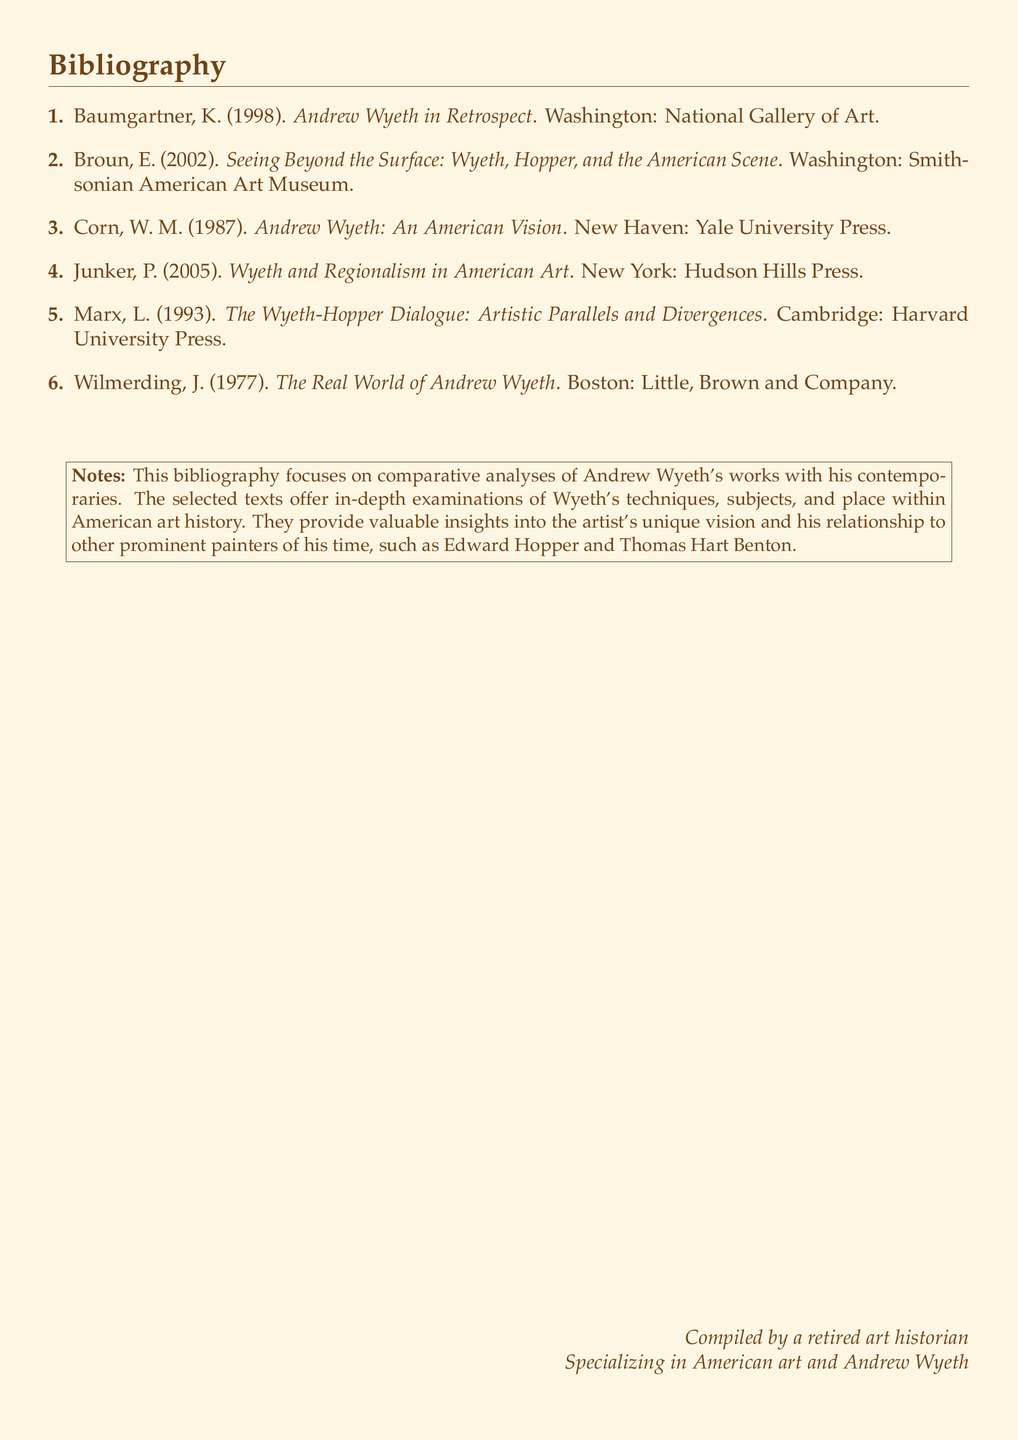What is the title of the book by K. Baumgartner? The title of the book is listed as "Andrew Wyeth in Retrospect."
Answer: Andrew Wyeth in Retrospect Who authored the work about Wyeth and Hopper? The work exploring the relationship between Wyeth and Hopper is authored by E. Broun.
Answer: E. Broun In what year was "The Wyeth-Hopper Dialogue" published? The year of publication for "The Wyeth-Hopper Dialogue" is noted as 1993.
Answer: 1993 Which publishing house released "Andrew Wyeth: An American Vision"? The publishing house mentioned for this work is Yale University Press.
Answer: Yale University Press What is the primary focus of the bibliography? The bibliography's primary focus is on comparative analyses of Andrew Wyeth's works with contemporaries.
Answer: Comparative analyses of Andrew Wyeth's works Who compiled this bibliography? The document specifies that it was compiled by a retired art historian.
Answer: A retired art historian How many items are listed in the bibliography? The total number of items listed in the bibliography is six.
Answer: Six What notable artist is mentioned alongside Wyeth in the critiques? The notable artist mentioned alongside Wyeth is Edward Hopper.
Answer: Edward Hopper 